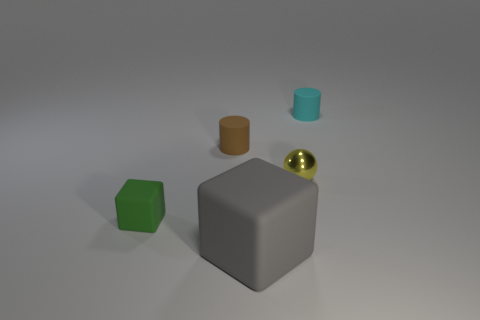Add 1 small metallic things. How many objects exist? 6 Add 1 tiny cyan cylinders. How many tiny cyan cylinders exist? 2 Subtract 1 cyan cylinders. How many objects are left? 4 Subtract all cubes. How many objects are left? 3 Subtract 1 cylinders. How many cylinders are left? 1 Subtract all cyan cylinders. Subtract all red cubes. How many cylinders are left? 1 Subtract all brown cubes. How many yellow cylinders are left? 0 Subtract all big blue objects. Subtract all tiny rubber objects. How many objects are left? 2 Add 5 big objects. How many big objects are left? 6 